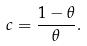Convert formula to latex. <formula><loc_0><loc_0><loc_500><loc_500>c = \frac { 1 - \theta } { \theta } .</formula> 